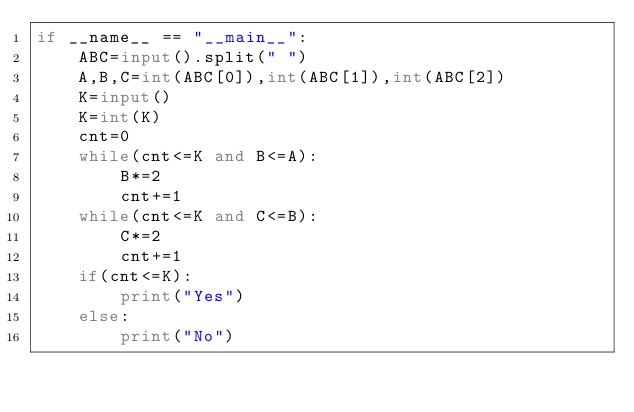Convert code to text. <code><loc_0><loc_0><loc_500><loc_500><_Python_>if __name__ == "__main__":
    ABC=input().split(" ")
    A,B,C=int(ABC[0]),int(ABC[1]),int(ABC[2])
    K=input()
    K=int(K)
    cnt=0
    while(cnt<=K and B<=A):
        B*=2
        cnt+=1
    while(cnt<=K and C<=B):
        C*=2
        cnt+=1
    if(cnt<=K):
        print("Yes")
    else:
        print("No")</code> 